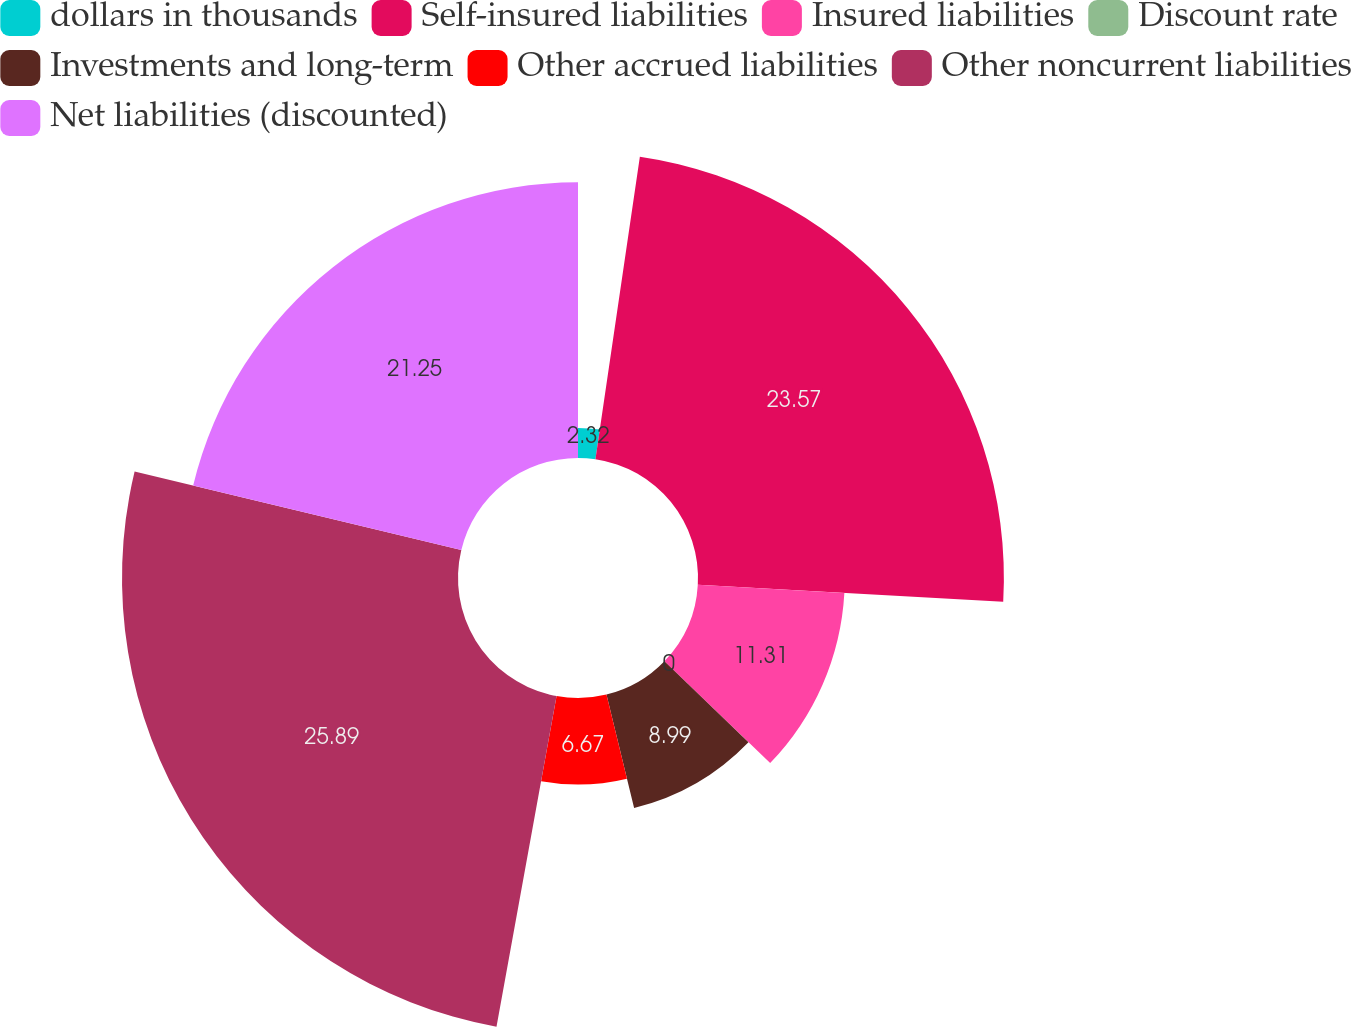Convert chart. <chart><loc_0><loc_0><loc_500><loc_500><pie_chart><fcel>dollars in thousands<fcel>Self-insured liabilities<fcel>Insured liabilities<fcel>Discount rate<fcel>Investments and long-term<fcel>Other accrued liabilities<fcel>Other noncurrent liabilities<fcel>Net liabilities (discounted)<nl><fcel>2.32%<fcel>23.57%<fcel>11.31%<fcel>0.0%<fcel>8.99%<fcel>6.67%<fcel>25.89%<fcel>21.25%<nl></chart> 